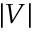Convert formula to latex. <formula><loc_0><loc_0><loc_500><loc_500>| V |</formula> 